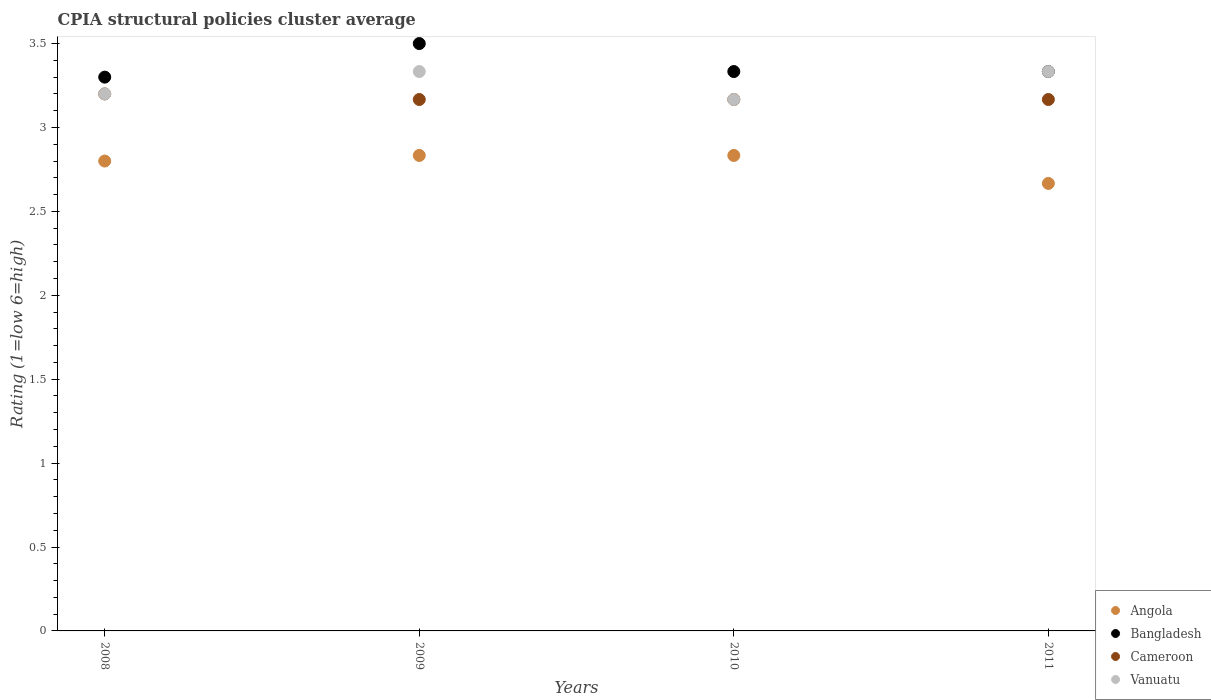How many different coloured dotlines are there?
Offer a very short reply. 4. What is the CPIA rating in Vanuatu in 2009?
Keep it short and to the point. 3.33. Across all years, what is the maximum CPIA rating in Vanuatu?
Your response must be concise. 3.33. Across all years, what is the minimum CPIA rating in Cameroon?
Ensure brevity in your answer.  3.17. In which year was the CPIA rating in Cameroon maximum?
Offer a terse response. 2008. What is the total CPIA rating in Bangladesh in the graph?
Your response must be concise. 13.47. What is the difference between the CPIA rating in Vanuatu in 2008 and that in 2011?
Make the answer very short. -0.13. What is the difference between the CPIA rating in Vanuatu in 2011 and the CPIA rating in Bangladesh in 2009?
Provide a succinct answer. -0.17. What is the average CPIA rating in Angola per year?
Provide a succinct answer. 2.78. What is the ratio of the CPIA rating in Angola in 2008 to that in 2010?
Provide a succinct answer. 0.99. Is the difference between the CPIA rating in Cameroon in 2008 and 2010 greater than the difference between the CPIA rating in Vanuatu in 2008 and 2010?
Ensure brevity in your answer.  No. What is the difference between the highest and the second highest CPIA rating in Cameroon?
Provide a succinct answer. 0.03. What is the difference between the highest and the lowest CPIA rating in Bangladesh?
Give a very brief answer. 0.2. In how many years, is the CPIA rating in Cameroon greater than the average CPIA rating in Cameroon taken over all years?
Keep it short and to the point. 1. Is the sum of the CPIA rating in Angola in 2009 and 2010 greater than the maximum CPIA rating in Bangladesh across all years?
Keep it short and to the point. Yes. Is it the case that in every year, the sum of the CPIA rating in Cameroon and CPIA rating in Bangladesh  is greater than the CPIA rating in Angola?
Your answer should be very brief. Yes. Does the CPIA rating in Bangladesh monotonically increase over the years?
Offer a terse response. No. Is the CPIA rating in Cameroon strictly less than the CPIA rating in Angola over the years?
Provide a short and direct response. No. Does the graph contain any zero values?
Your answer should be very brief. No. Does the graph contain grids?
Provide a short and direct response. No. How are the legend labels stacked?
Offer a terse response. Vertical. What is the title of the graph?
Offer a terse response. CPIA structural policies cluster average. Does "Macao" appear as one of the legend labels in the graph?
Give a very brief answer. No. What is the label or title of the Y-axis?
Ensure brevity in your answer.  Rating (1=low 6=high). What is the Rating (1=low 6=high) of Cameroon in 2008?
Offer a very short reply. 3.2. What is the Rating (1=low 6=high) in Vanuatu in 2008?
Your response must be concise. 3.2. What is the Rating (1=low 6=high) in Angola in 2009?
Provide a succinct answer. 2.83. What is the Rating (1=low 6=high) in Bangladesh in 2009?
Your answer should be compact. 3.5. What is the Rating (1=low 6=high) of Cameroon in 2009?
Provide a short and direct response. 3.17. What is the Rating (1=low 6=high) in Vanuatu in 2009?
Provide a succinct answer. 3.33. What is the Rating (1=low 6=high) of Angola in 2010?
Offer a terse response. 2.83. What is the Rating (1=low 6=high) of Bangladesh in 2010?
Your answer should be compact. 3.33. What is the Rating (1=low 6=high) of Cameroon in 2010?
Make the answer very short. 3.17. What is the Rating (1=low 6=high) of Vanuatu in 2010?
Keep it short and to the point. 3.17. What is the Rating (1=low 6=high) in Angola in 2011?
Give a very brief answer. 2.67. What is the Rating (1=low 6=high) in Bangladesh in 2011?
Make the answer very short. 3.33. What is the Rating (1=low 6=high) in Cameroon in 2011?
Your answer should be compact. 3.17. What is the Rating (1=low 6=high) of Vanuatu in 2011?
Ensure brevity in your answer.  3.33. Across all years, what is the maximum Rating (1=low 6=high) in Angola?
Ensure brevity in your answer.  2.83. Across all years, what is the maximum Rating (1=low 6=high) in Cameroon?
Your answer should be compact. 3.2. Across all years, what is the maximum Rating (1=low 6=high) of Vanuatu?
Offer a terse response. 3.33. Across all years, what is the minimum Rating (1=low 6=high) in Angola?
Your answer should be compact. 2.67. Across all years, what is the minimum Rating (1=low 6=high) of Cameroon?
Keep it short and to the point. 3.17. Across all years, what is the minimum Rating (1=low 6=high) in Vanuatu?
Offer a very short reply. 3.17. What is the total Rating (1=low 6=high) in Angola in the graph?
Keep it short and to the point. 11.13. What is the total Rating (1=low 6=high) in Bangladesh in the graph?
Give a very brief answer. 13.47. What is the total Rating (1=low 6=high) in Cameroon in the graph?
Ensure brevity in your answer.  12.7. What is the total Rating (1=low 6=high) in Vanuatu in the graph?
Keep it short and to the point. 13.03. What is the difference between the Rating (1=low 6=high) in Angola in 2008 and that in 2009?
Make the answer very short. -0.03. What is the difference between the Rating (1=low 6=high) of Bangladesh in 2008 and that in 2009?
Provide a short and direct response. -0.2. What is the difference between the Rating (1=low 6=high) of Cameroon in 2008 and that in 2009?
Provide a succinct answer. 0.03. What is the difference between the Rating (1=low 6=high) in Vanuatu in 2008 and that in 2009?
Make the answer very short. -0.13. What is the difference between the Rating (1=low 6=high) in Angola in 2008 and that in 2010?
Offer a terse response. -0.03. What is the difference between the Rating (1=low 6=high) in Bangladesh in 2008 and that in 2010?
Your response must be concise. -0.03. What is the difference between the Rating (1=low 6=high) in Cameroon in 2008 and that in 2010?
Provide a succinct answer. 0.03. What is the difference between the Rating (1=low 6=high) of Vanuatu in 2008 and that in 2010?
Give a very brief answer. 0.03. What is the difference between the Rating (1=low 6=high) in Angola in 2008 and that in 2011?
Offer a terse response. 0.13. What is the difference between the Rating (1=low 6=high) in Bangladesh in 2008 and that in 2011?
Offer a very short reply. -0.03. What is the difference between the Rating (1=low 6=high) of Vanuatu in 2008 and that in 2011?
Offer a terse response. -0.13. What is the difference between the Rating (1=low 6=high) of Cameroon in 2009 and that in 2010?
Your answer should be very brief. 0. What is the difference between the Rating (1=low 6=high) in Vanuatu in 2009 and that in 2010?
Provide a succinct answer. 0.17. What is the difference between the Rating (1=low 6=high) in Vanuatu in 2009 and that in 2011?
Provide a succinct answer. 0. What is the difference between the Rating (1=low 6=high) of Angola in 2010 and that in 2011?
Your answer should be compact. 0.17. What is the difference between the Rating (1=low 6=high) of Cameroon in 2010 and that in 2011?
Your response must be concise. 0. What is the difference between the Rating (1=low 6=high) of Angola in 2008 and the Rating (1=low 6=high) of Cameroon in 2009?
Make the answer very short. -0.37. What is the difference between the Rating (1=low 6=high) in Angola in 2008 and the Rating (1=low 6=high) in Vanuatu in 2009?
Provide a succinct answer. -0.53. What is the difference between the Rating (1=low 6=high) in Bangladesh in 2008 and the Rating (1=low 6=high) in Cameroon in 2009?
Provide a short and direct response. 0.13. What is the difference between the Rating (1=low 6=high) in Bangladesh in 2008 and the Rating (1=low 6=high) in Vanuatu in 2009?
Your response must be concise. -0.03. What is the difference between the Rating (1=low 6=high) in Cameroon in 2008 and the Rating (1=low 6=high) in Vanuatu in 2009?
Your response must be concise. -0.13. What is the difference between the Rating (1=low 6=high) of Angola in 2008 and the Rating (1=low 6=high) of Bangladesh in 2010?
Provide a short and direct response. -0.53. What is the difference between the Rating (1=low 6=high) of Angola in 2008 and the Rating (1=low 6=high) of Cameroon in 2010?
Your answer should be compact. -0.37. What is the difference between the Rating (1=low 6=high) in Angola in 2008 and the Rating (1=low 6=high) in Vanuatu in 2010?
Ensure brevity in your answer.  -0.37. What is the difference between the Rating (1=low 6=high) in Bangladesh in 2008 and the Rating (1=low 6=high) in Cameroon in 2010?
Provide a succinct answer. 0.13. What is the difference between the Rating (1=low 6=high) in Bangladesh in 2008 and the Rating (1=low 6=high) in Vanuatu in 2010?
Offer a very short reply. 0.13. What is the difference between the Rating (1=low 6=high) of Cameroon in 2008 and the Rating (1=low 6=high) of Vanuatu in 2010?
Your response must be concise. 0.03. What is the difference between the Rating (1=low 6=high) in Angola in 2008 and the Rating (1=low 6=high) in Bangladesh in 2011?
Offer a terse response. -0.53. What is the difference between the Rating (1=low 6=high) in Angola in 2008 and the Rating (1=low 6=high) in Cameroon in 2011?
Make the answer very short. -0.37. What is the difference between the Rating (1=low 6=high) in Angola in 2008 and the Rating (1=low 6=high) in Vanuatu in 2011?
Your answer should be very brief. -0.53. What is the difference between the Rating (1=low 6=high) in Bangladesh in 2008 and the Rating (1=low 6=high) in Cameroon in 2011?
Provide a succinct answer. 0.13. What is the difference between the Rating (1=low 6=high) in Bangladesh in 2008 and the Rating (1=low 6=high) in Vanuatu in 2011?
Make the answer very short. -0.03. What is the difference between the Rating (1=low 6=high) of Cameroon in 2008 and the Rating (1=low 6=high) of Vanuatu in 2011?
Ensure brevity in your answer.  -0.13. What is the difference between the Rating (1=low 6=high) of Angola in 2009 and the Rating (1=low 6=high) of Cameroon in 2010?
Offer a terse response. -0.33. What is the difference between the Rating (1=low 6=high) in Bangladesh in 2009 and the Rating (1=low 6=high) in Vanuatu in 2010?
Keep it short and to the point. 0.33. What is the difference between the Rating (1=low 6=high) in Cameroon in 2009 and the Rating (1=low 6=high) in Vanuatu in 2010?
Ensure brevity in your answer.  0. What is the difference between the Rating (1=low 6=high) in Angola in 2009 and the Rating (1=low 6=high) in Cameroon in 2011?
Keep it short and to the point. -0.33. What is the difference between the Rating (1=low 6=high) in Bangladesh in 2009 and the Rating (1=low 6=high) in Vanuatu in 2011?
Provide a succinct answer. 0.17. What is the difference between the Rating (1=low 6=high) in Cameroon in 2009 and the Rating (1=low 6=high) in Vanuatu in 2011?
Ensure brevity in your answer.  -0.17. What is the difference between the Rating (1=low 6=high) in Angola in 2010 and the Rating (1=low 6=high) in Bangladesh in 2011?
Provide a succinct answer. -0.5. What is the difference between the Rating (1=low 6=high) in Bangladesh in 2010 and the Rating (1=low 6=high) in Cameroon in 2011?
Your response must be concise. 0.17. What is the average Rating (1=low 6=high) in Angola per year?
Your answer should be very brief. 2.78. What is the average Rating (1=low 6=high) of Bangladesh per year?
Provide a succinct answer. 3.37. What is the average Rating (1=low 6=high) of Cameroon per year?
Provide a short and direct response. 3.17. What is the average Rating (1=low 6=high) of Vanuatu per year?
Keep it short and to the point. 3.26. In the year 2008, what is the difference between the Rating (1=low 6=high) in Angola and Rating (1=low 6=high) in Cameroon?
Provide a short and direct response. -0.4. In the year 2008, what is the difference between the Rating (1=low 6=high) of Angola and Rating (1=low 6=high) of Vanuatu?
Ensure brevity in your answer.  -0.4. In the year 2009, what is the difference between the Rating (1=low 6=high) in Angola and Rating (1=low 6=high) in Cameroon?
Provide a succinct answer. -0.33. In the year 2010, what is the difference between the Rating (1=low 6=high) in Angola and Rating (1=low 6=high) in Bangladesh?
Your response must be concise. -0.5. In the year 2010, what is the difference between the Rating (1=low 6=high) in Angola and Rating (1=low 6=high) in Cameroon?
Make the answer very short. -0.33. In the year 2010, what is the difference between the Rating (1=low 6=high) in Bangladesh and Rating (1=low 6=high) in Vanuatu?
Keep it short and to the point. 0.17. In the year 2010, what is the difference between the Rating (1=low 6=high) of Cameroon and Rating (1=low 6=high) of Vanuatu?
Offer a terse response. 0. In the year 2011, what is the difference between the Rating (1=low 6=high) of Angola and Rating (1=low 6=high) of Bangladesh?
Give a very brief answer. -0.67. In the year 2011, what is the difference between the Rating (1=low 6=high) in Angola and Rating (1=low 6=high) in Cameroon?
Provide a succinct answer. -0.5. In the year 2011, what is the difference between the Rating (1=low 6=high) in Bangladesh and Rating (1=low 6=high) in Vanuatu?
Your answer should be compact. 0. What is the ratio of the Rating (1=low 6=high) of Bangladesh in 2008 to that in 2009?
Your answer should be compact. 0.94. What is the ratio of the Rating (1=low 6=high) of Cameroon in 2008 to that in 2009?
Offer a terse response. 1.01. What is the ratio of the Rating (1=low 6=high) in Bangladesh in 2008 to that in 2010?
Your answer should be compact. 0.99. What is the ratio of the Rating (1=low 6=high) of Cameroon in 2008 to that in 2010?
Ensure brevity in your answer.  1.01. What is the ratio of the Rating (1=low 6=high) of Vanuatu in 2008 to that in 2010?
Offer a terse response. 1.01. What is the ratio of the Rating (1=low 6=high) in Angola in 2008 to that in 2011?
Provide a succinct answer. 1.05. What is the ratio of the Rating (1=low 6=high) of Cameroon in 2008 to that in 2011?
Offer a very short reply. 1.01. What is the ratio of the Rating (1=low 6=high) in Vanuatu in 2008 to that in 2011?
Provide a short and direct response. 0.96. What is the ratio of the Rating (1=low 6=high) of Angola in 2009 to that in 2010?
Provide a short and direct response. 1. What is the ratio of the Rating (1=low 6=high) of Vanuatu in 2009 to that in 2010?
Provide a short and direct response. 1.05. What is the ratio of the Rating (1=low 6=high) in Bangladesh in 2009 to that in 2011?
Make the answer very short. 1.05. What is the ratio of the Rating (1=low 6=high) in Cameroon in 2009 to that in 2011?
Provide a succinct answer. 1. What is the ratio of the Rating (1=low 6=high) of Angola in 2010 to that in 2011?
Give a very brief answer. 1.06. What is the ratio of the Rating (1=low 6=high) in Bangladesh in 2010 to that in 2011?
Make the answer very short. 1. What is the ratio of the Rating (1=low 6=high) of Cameroon in 2010 to that in 2011?
Provide a succinct answer. 1. What is the difference between the highest and the second highest Rating (1=low 6=high) of Angola?
Your response must be concise. 0. What is the difference between the highest and the second highest Rating (1=low 6=high) in Bangladesh?
Your answer should be very brief. 0.17. What is the difference between the highest and the second highest Rating (1=low 6=high) of Cameroon?
Your response must be concise. 0.03. What is the difference between the highest and the lowest Rating (1=low 6=high) in Angola?
Your response must be concise. 0.17. What is the difference between the highest and the lowest Rating (1=low 6=high) in Bangladesh?
Make the answer very short. 0.2. 